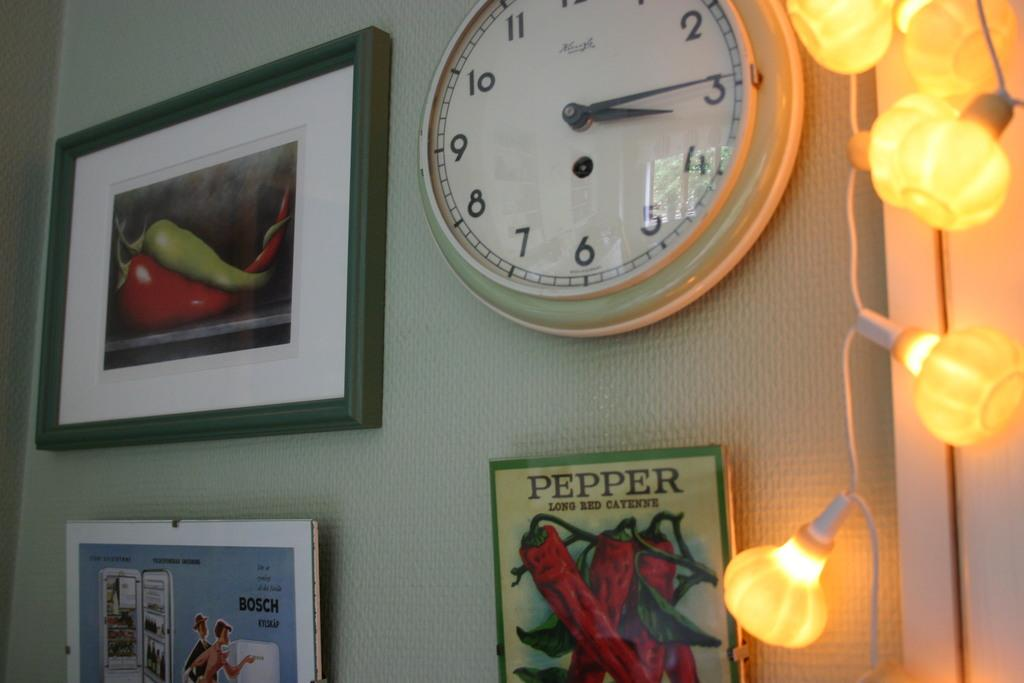<image>
Share a concise interpretation of the image provided. Clock on top of a poster which says Pepper. 